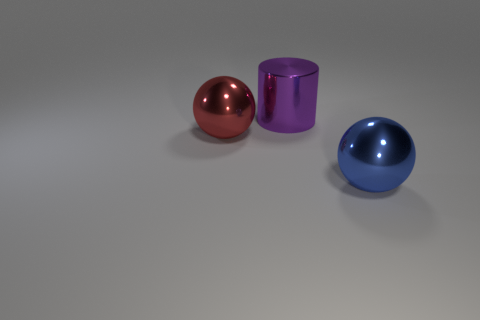Add 2 big cylinders. How many objects exist? 5 Subtract all balls. How many objects are left? 1 Subtract 0 green cylinders. How many objects are left? 3 Subtract all blue objects. Subtract all big purple shiny objects. How many objects are left? 1 Add 1 red objects. How many red objects are left? 2 Add 2 shiny spheres. How many shiny spheres exist? 4 